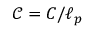<formula> <loc_0><loc_0><loc_500><loc_500>\mathcal { C } = C / \ell _ { p }</formula> 